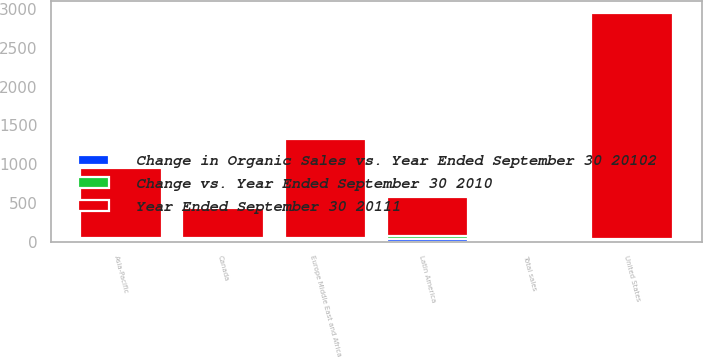<chart> <loc_0><loc_0><loc_500><loc_500><stacked_bar_chart><ecel><fcel>United States<fcel>Canada<fcel>Europe Middle East and Africa<fcel>Asia-Pacific<fcel>Latin America<fcel>Total sales<nl><fcel>Year Ended September 30 20111<fcel>2917.8<fcel>396.2<fcel>1267.6<fcel>910.6<fcel>508.2<fcel>26<nl><fcel>Change vs. Year Ended September 30 2010<fcel>19<fcel>23<fcel>28<fcel>26<fcel>38<fcel>24<nl><fcel>Change in Organic Sales vs. Year Ended September 30 20102<fcel>18<fcel>17<fcel>22<fcel>18<fcel>30<fcel>20<nl></chart> 